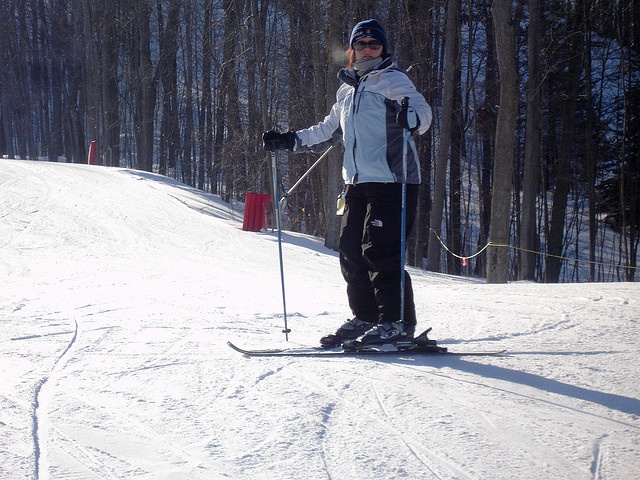Describe the objects in this image and their specific colors. I can see people in black, gray, and navy tones and skis in black, white, and gray tones in this image. 